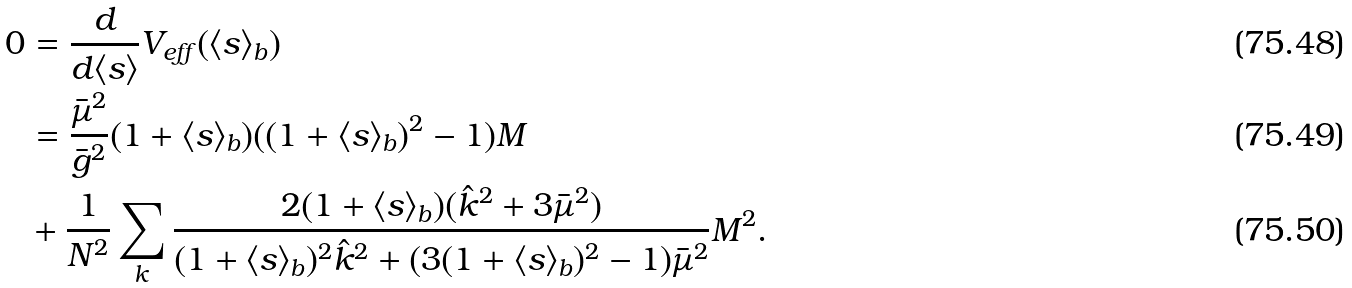Convert formula to latex. <formula><loc_0><loc_0><loc_500><loc_500>0 & = \frac { d } { d \langle s \rangle } V _ { e f f } ( \langle s \rangle _ { b } ) \\ & = \frac { \bar { \mu } ^ { 2 } } { \bar { g } ^ { 2 } } ( 1 + \langle s \rangle _ { b } ) ( ( 1 + \langle s \rangle _ { b } ) ^ { 2 } - 1 ) M \\ & + \frac { 1 } { N ^ { 2 } } \sum _ { k } \frac { 2 ( 1 + \langle s \rangle _ { b } ) ( \hat { k } ^ { 2 } + 3 \bar { \mu } ^ { 2 } ) } { ( 1 + \langle s \rangle _ { b } ) ^ { 2 } \hat { k } ^ { 2 } + ( 3 ( 1 + \langle s \rangle _ { b } ) ^ { 2 } - 1 ) \bar { \mu } ^ { 2 } } M ^ { 2 } .</formula> 